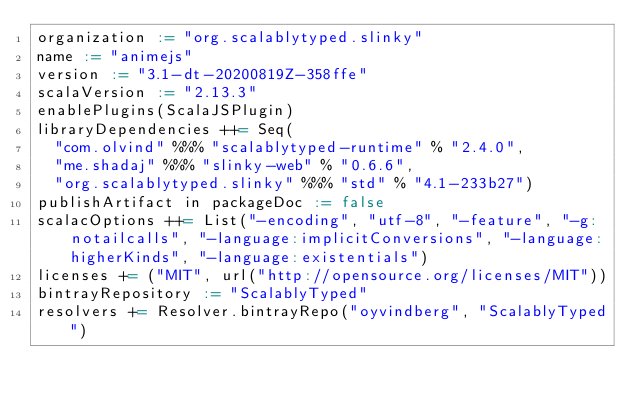Convert code to text. <code><loc_0><loc_0><loc_500><loc_500><_Scala_>organization := "org.scalablytyped.slinky"
name := "animejs"
version := "3.1-dt-20200819Z-358ffe"
scalaVersion := "2.13.3"
enablePlugins(ScalaJSPlugin)
libraryDependencies ++= Seq(
  "com.olvind" %%% "scalablytyped-runtime" % "2.4.0",
  "me.shadaj" %%% "slinky-web" % "0.6.6",
  "org.scalablytyped.slinky" %%% "std" % "4.1-233b27")
publishArtifact in packageDoc := false
scalacOptions ++= List("-encoding", "utf-8", "-feature", "-g:notailcalls", "-language:implicitConversions", "-language:higherKinds", "-language:existentials")
licenses += ("MIT", url("http://opensource.org/licenses/MIT"))
bintrayRepository := "ScalablyTyped"
resolvers += Resolver.bintrayRepo("oyvindberg", "ScalablyTyped")
</code> 